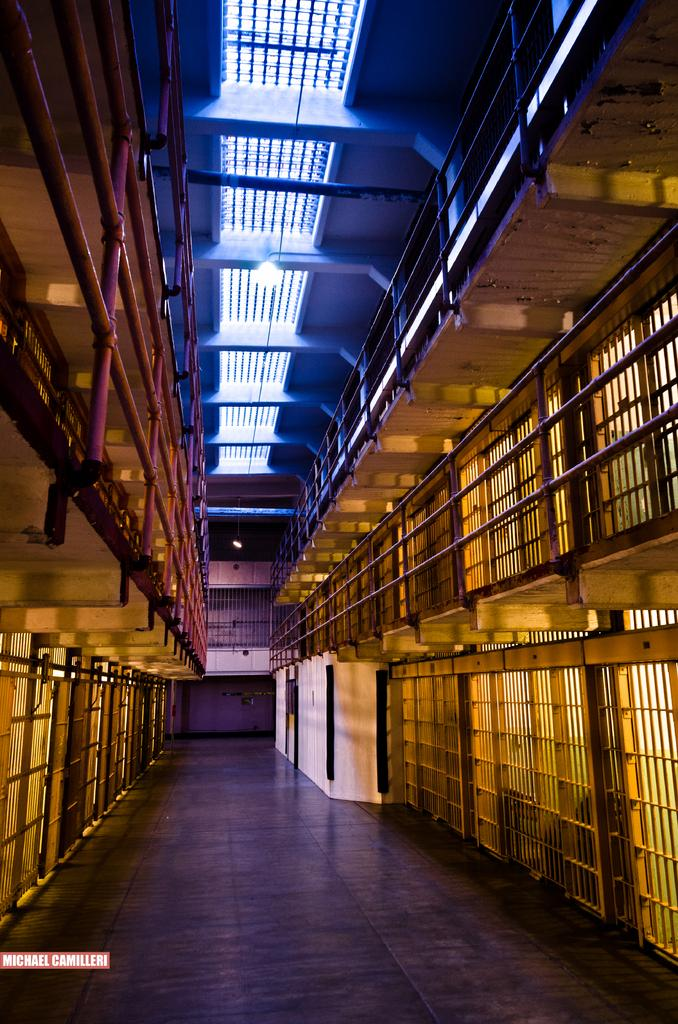What type of structure is depicted in the image? The image is of a building. What can be seen at the top of the building? There are pipes at the top of the building. What feature is present in the image that might be used for safety or support? There is a railing in the image. What can be seen providing illumination in the image? There are lights in the image. What is the lowest level of the building visible in the image? There is a floor at the bottom of the building. How much does the weight of the alley contribute to the overall structure of the building in the image? There is no alley present in the image, so its weight cannot contribute to the building's structure. What type of coin can be seen on the floor of the building in the image? There is no coin, including a dime, present on the floor of the building in the image. 